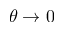Convert formula to latex. <formula><loc_0><loc_0><loc_500><loc_500>\theta \rightarrow 0</formula> 